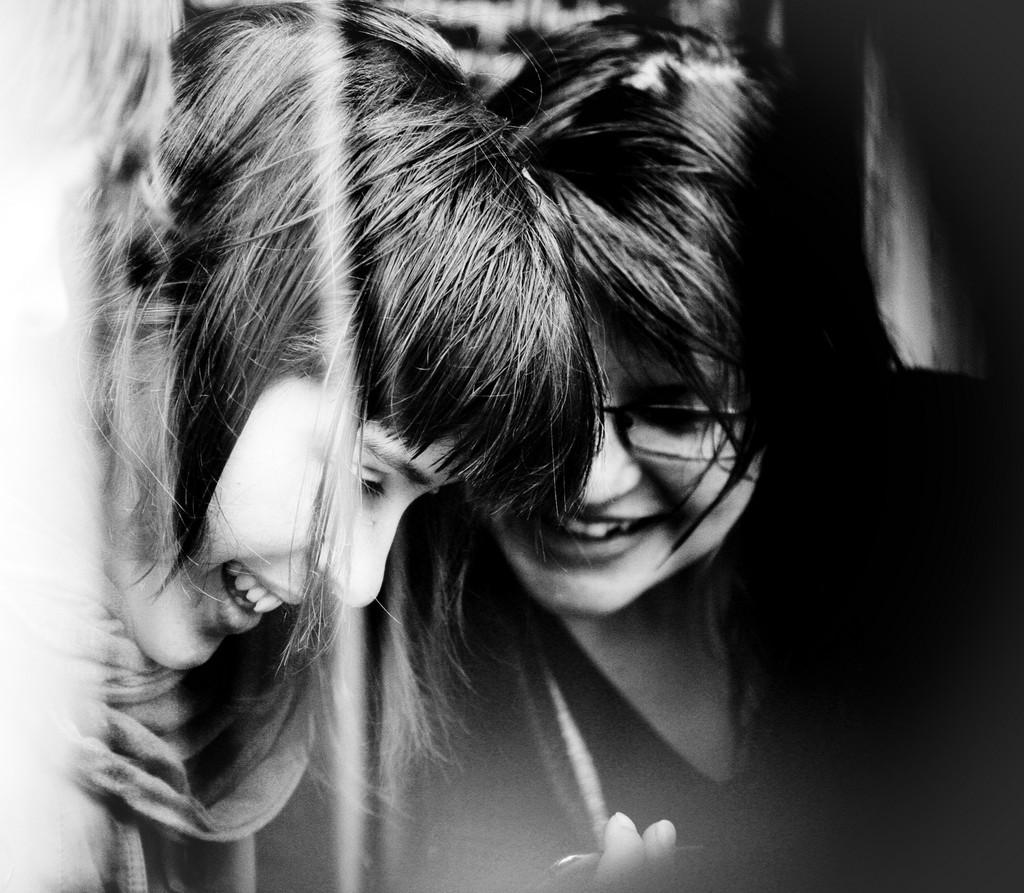How many people are in the image? There are two girls in the image. What is the color scheme of the image? The image is black and white. Can you describe the background of the image? The background of the image is blurred. What is one girl wearing in the image? One girl is wearing a scarf on the left side of the image. What type of hen can be seen in the image? There is no hen present in the image. What is the horsepower of the engine in the image? There is no engine present in the image. 